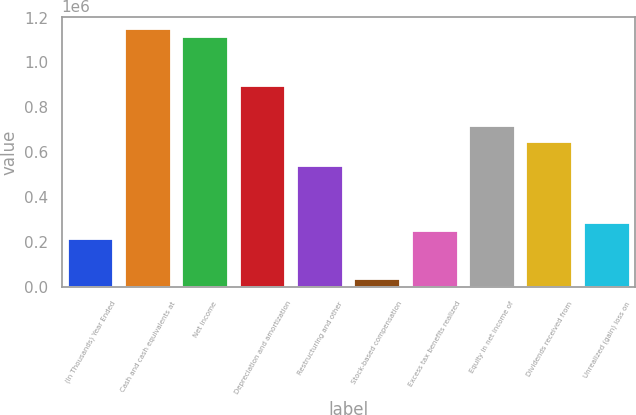Convert chart to OTSL. <chart><loc_0><loc_0><loc_500><loc_500><bar_chart><fcel>(In Thousands) Year Ended<fcel>Cash and cash equivalents at<fcel>Net income<fcel>Depreciation and amortization<fcel>Restructuring and other<fcel>Stock-based compensation<fcel>Excess tax benefits realized<fcel>Equity in net income of<fcel>Dividends received from<fcel>Unrealized (gain) loss on<nl><fcel>215131<fcel>1.14719e+06<fcel>1.11134e+06<fcel>896252<fcel>537768<fcel>35888.5<fcel>250980<fcel>717010<fcel>645313<fcel>286828<nl></chart> 